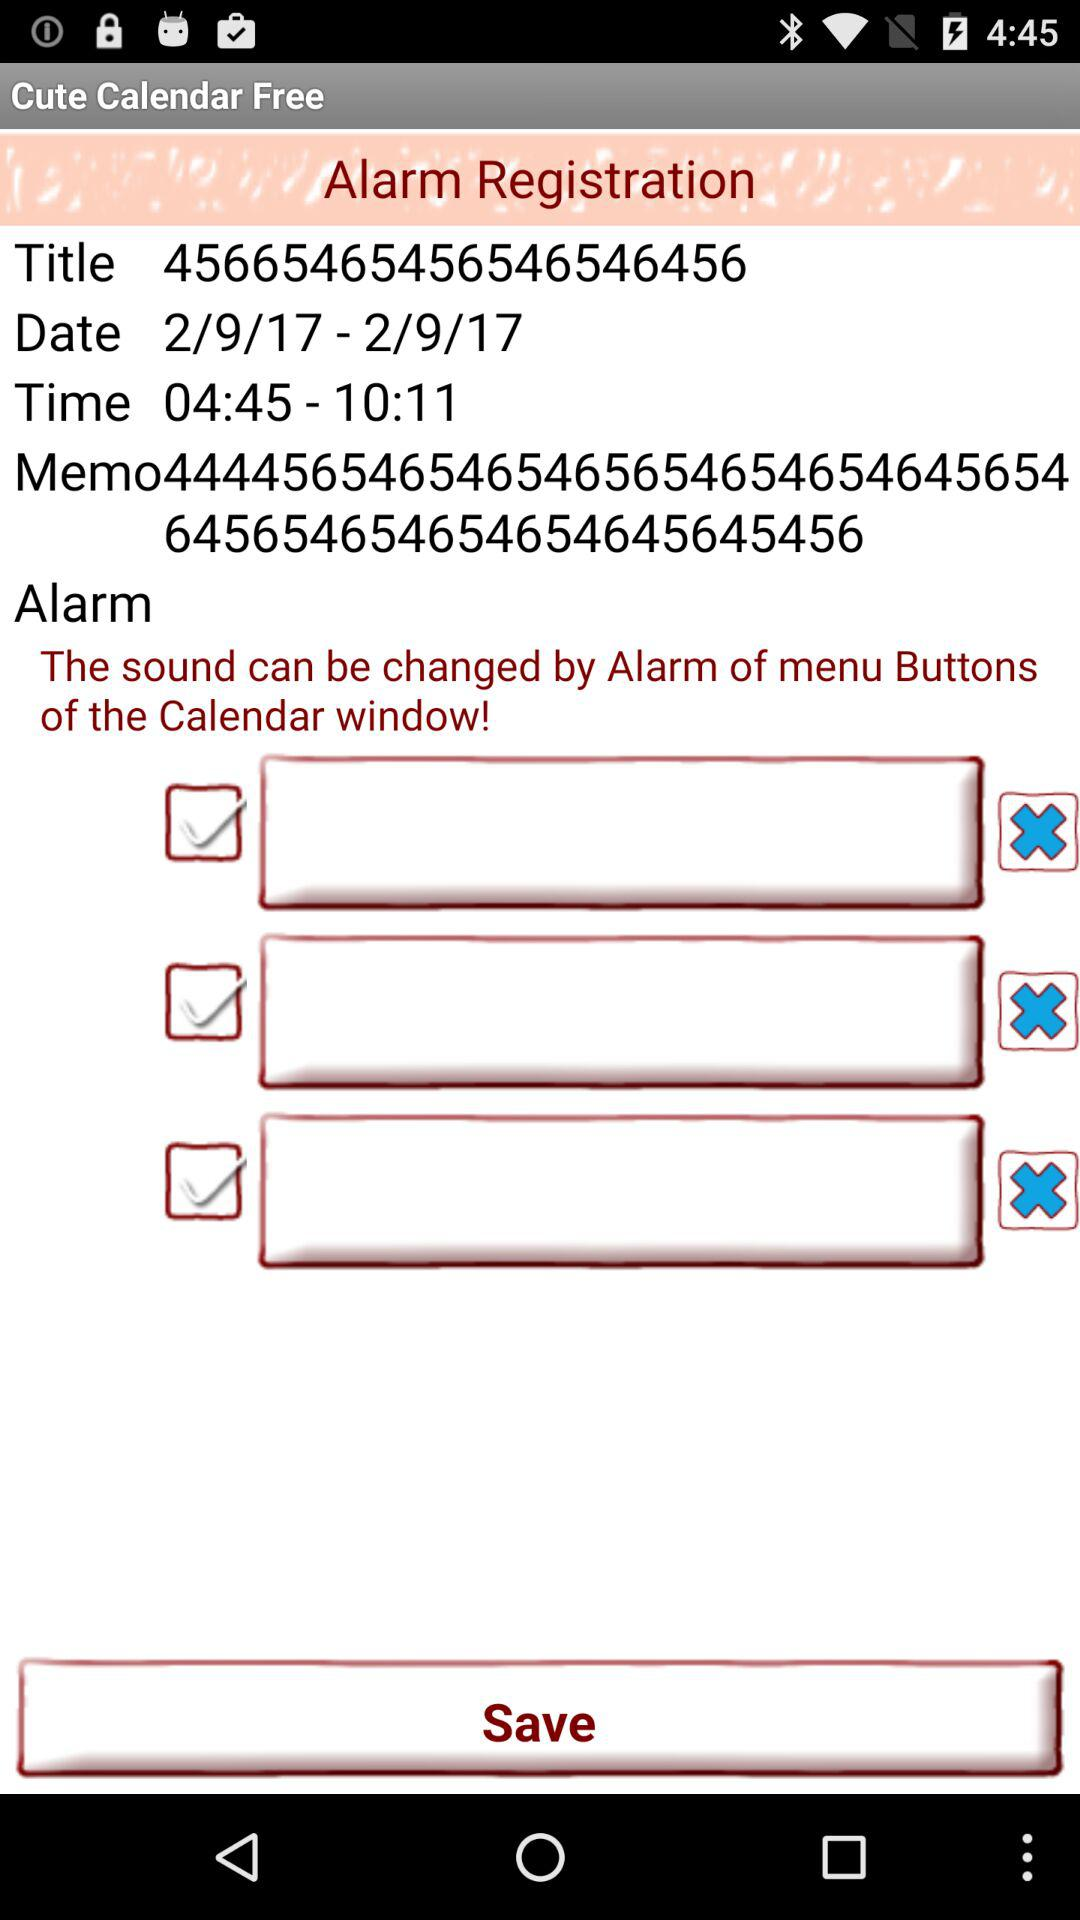What is the time range? The time ranges from 04:45 to 10:11. 